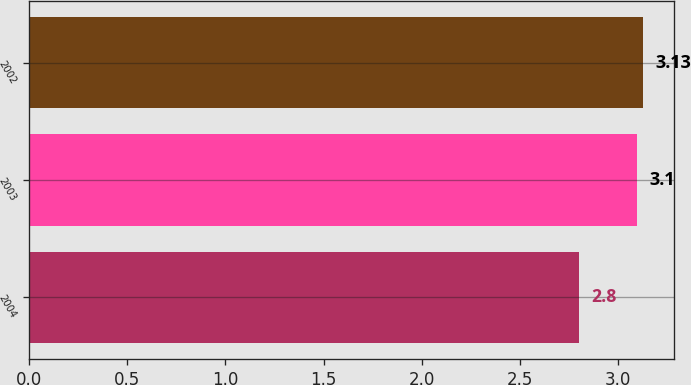<chart> <loc_0><loc_0><loc_500><loc_500><bar_chart><fcel>2004<fcel>2003<fcel>2002<nl><fcel>2.8<fcel>3.1<fcel>3.13<nl></chart> 